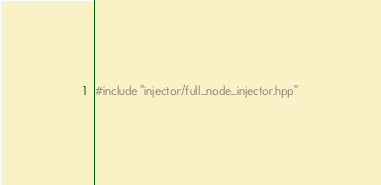Convert code to text. <code><loc_0><loc_0><loc_500><loc_500><_C++_>#include "injector/full_node_injector.hpp"
</code> 